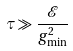<formula> <loc_0><loc_0><loc_500><loc_500>\tau \gg \frac { \mathcal { E } } { g _ { \min } ^ { 2 } }</formula> 